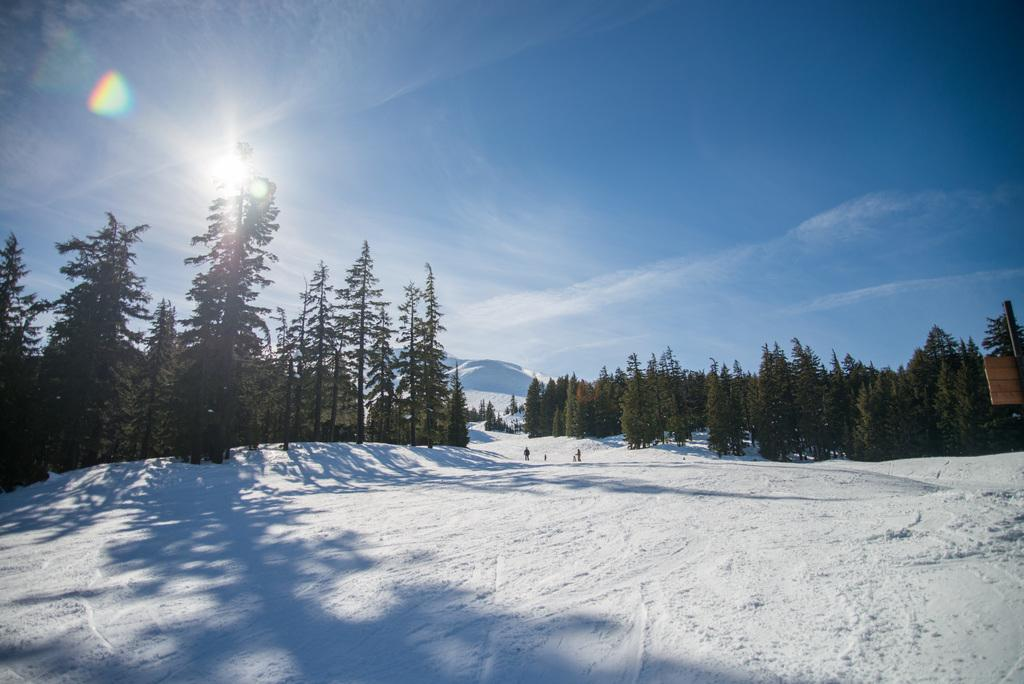What is the overall appearance of the image? The image is covered in snow. What color is the snow in the image? The snow is white in color. What can be seen in the image besides the snow? There are people standing in the snow, a mountain, trees, and the sky is visible with the sun visible in it. Where is the toothbrush located in the image? There is no toothbrush present in the image. What type of fuel is being used by the people in the image? There is no mention of fuel or any vehicles in the image, as it primarily features people standing in the snow with a mountain and trees in the background. 